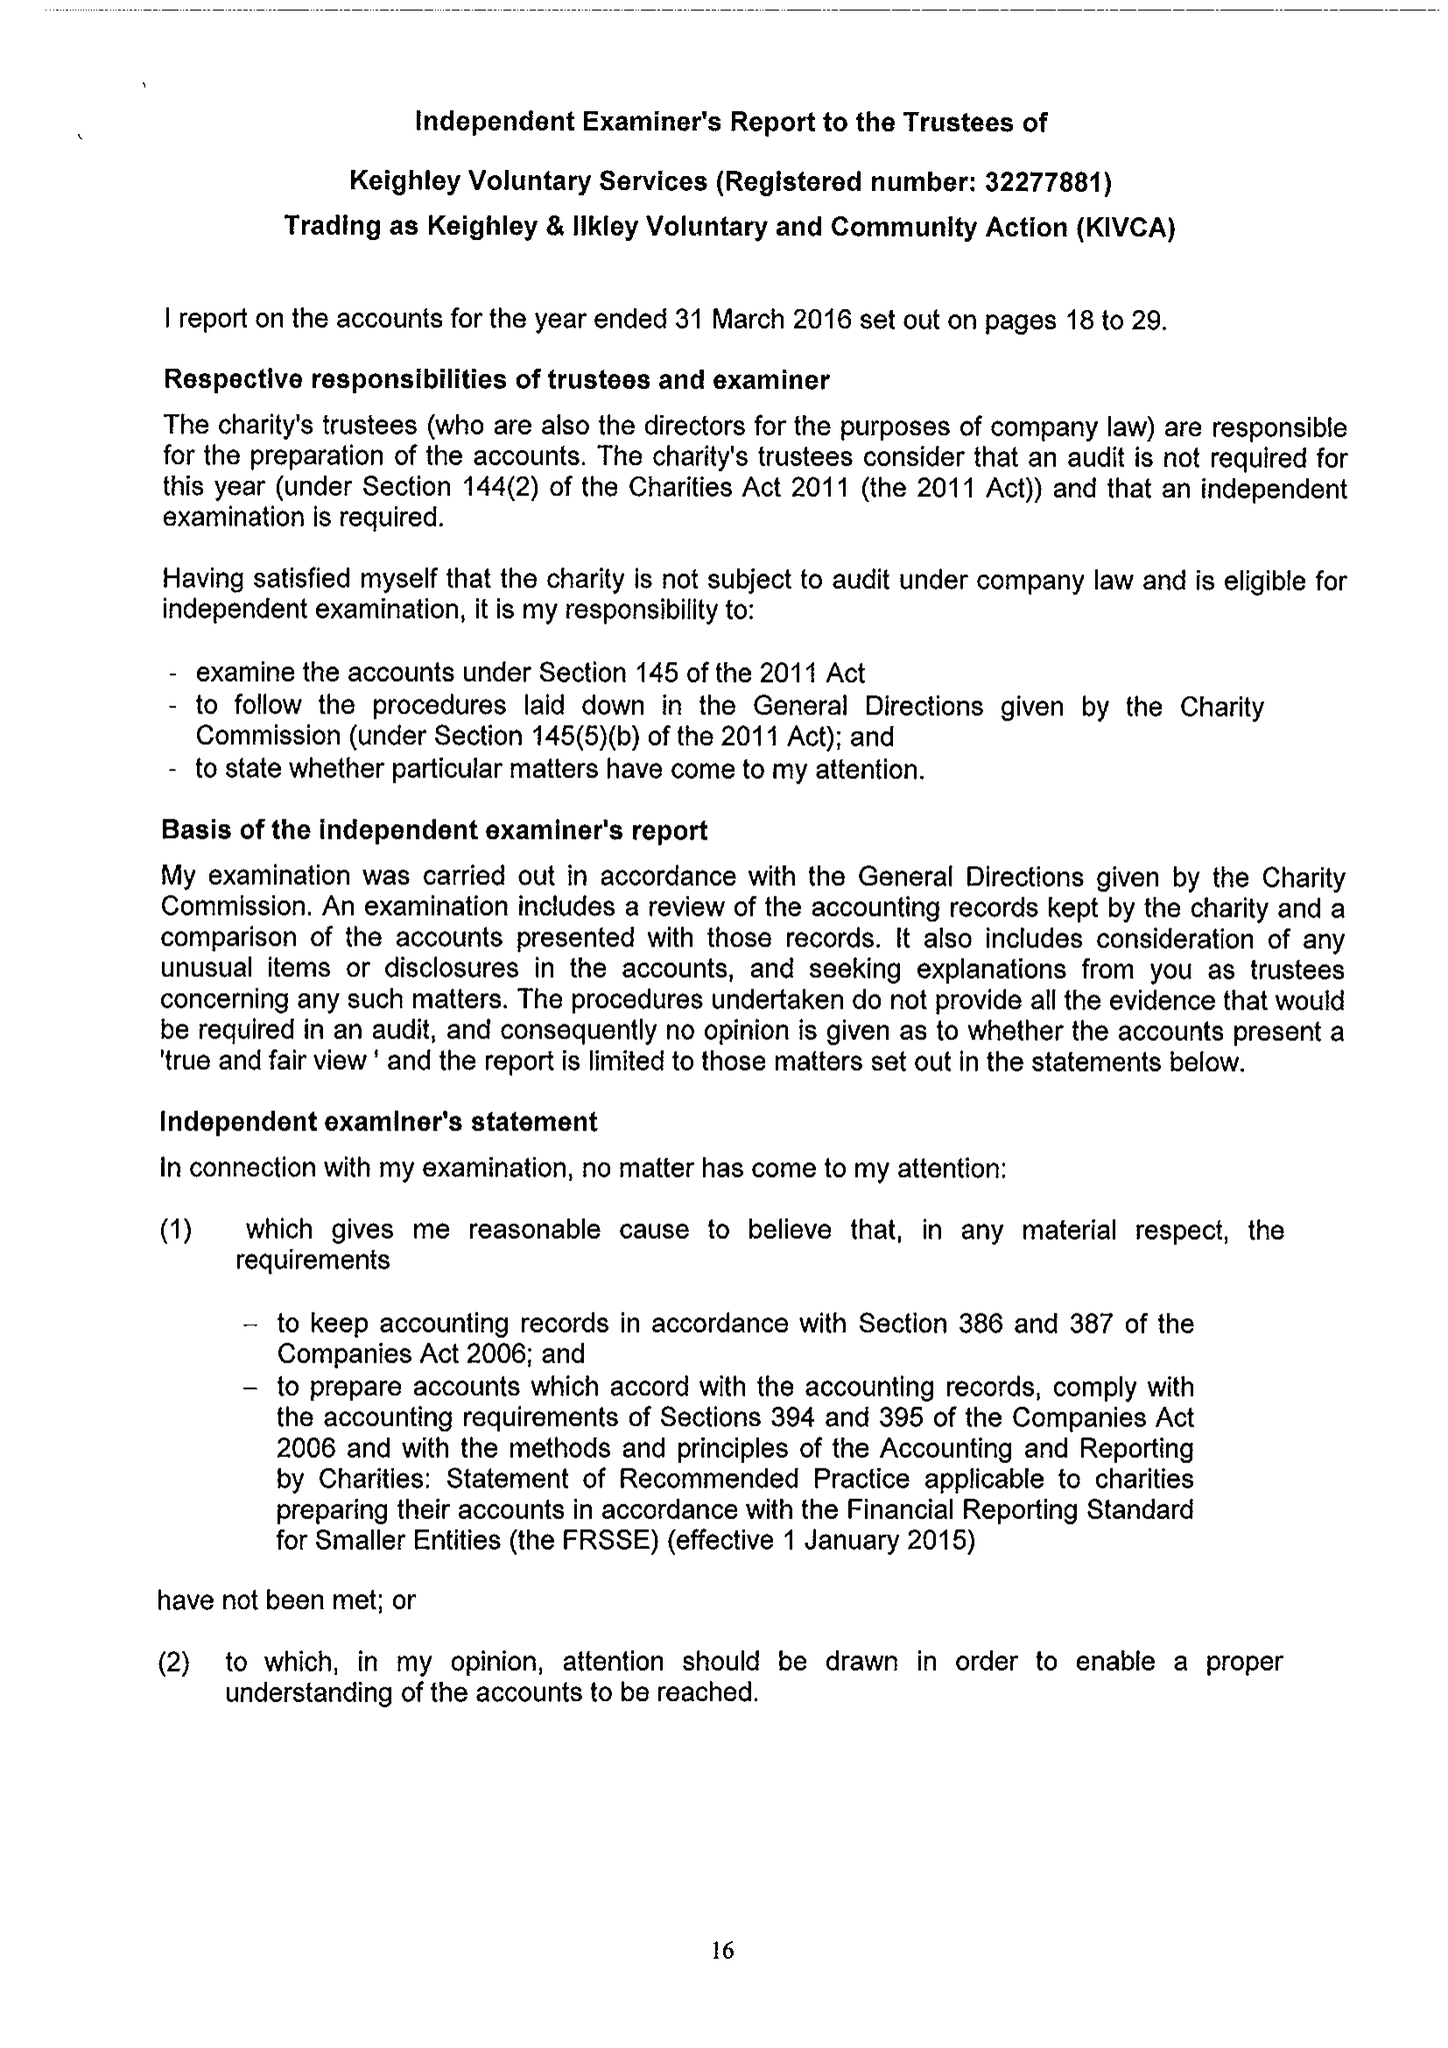What is the value for the address__post_town?
Answer the question using a single word or phrase. KEIGHLEY 